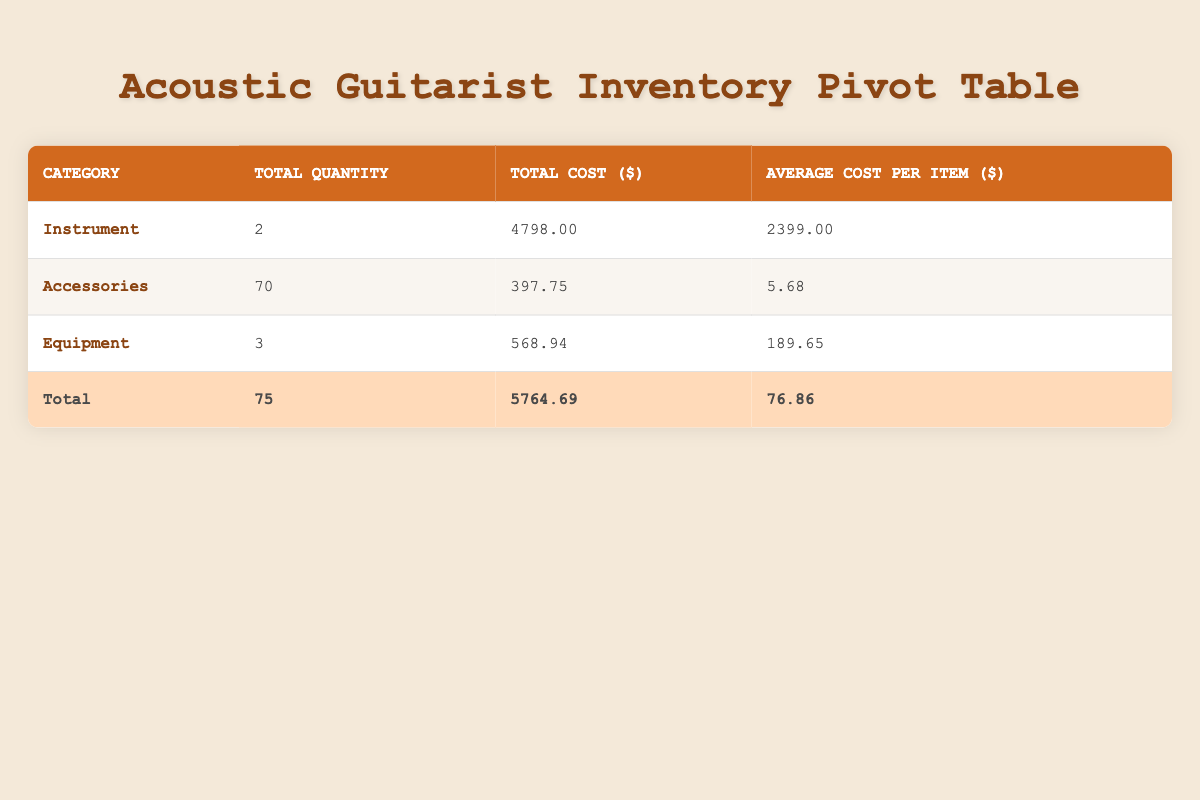What is the total quantity of items in the Accessories category? The total quantity of items in the Accessories category is shown in the corresponding row of the table. It is stated as 70 in the "Total Quantity" column for Accessories.
Answer: 70 What is the total cost of all Instruments in the inventory? The total cost of the Instruments is provided directly in the table under the "Total Cost ($)" column for the Instrument category, which is 4798.00.
Answer: 4798.00 What is the average cost of Equipment items? The average cost for Equipment items can be calculated from the given "Average Cost per Item ($)" in the Equipment row, which states 189.65.
Answer: 189.65 Is the total number of items greater than 70? The total number of items is shown in the last row as 75, which is greater than 70, confirming that the statement is true.
Answer: Yes Which category has the highest average cost per item? By comparing the average costs per item across categories, in the table, we see that the Instruments category, with an average cost of 2399.00, is higher than both Accessories (5.68) and Equipment (189.65).
Answer: Instruments What is the total cost of all items in the inventory? The total cost of all items is given in the last row under "Total Cost ($)" as 5764.69. This value accounts for the costs of all items combined in the inventory.
Answer: 5764.69 Are there any items in the Equipment category that cost less than $100? A quick review of the Equipment category shows the Shure SM58 Microphone and Boss TU-3 Chromatic Tuner Pedal, both of which cost $99 and $99.99 respectively. Therefore, there are no items priced under $100.
Answer: No How many more Accessories items are there than Equipment items? The Accessories category has a total quantity of 70, and the Equipment category has a total of 3. Subtracting these gives 70 - 3 = 67. This shows there are 67 more Accessories items than Equipment items.
Answer: 67 What is the average cost of all items in the inventory? To calculate the average cost of all items, we take the total cost ($5764.69) and divide it by the total quantity (75). Performing this calculation results in an average cost of approximately 76.86.
Answer: 76.86 